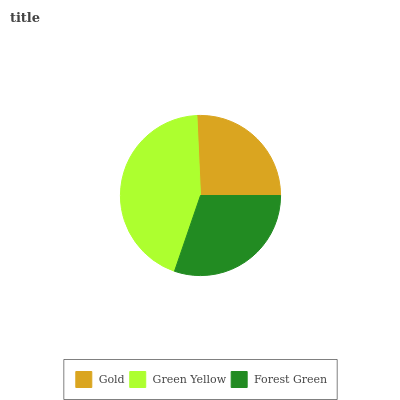Is Gold the minimum?
Answer yes or no. Yes. Is Green Yellow the maximum?
Answer yes or no. Yes. Is Forest Green the minimum?
Answer yes or no. No. Is Forest Green the maximum?
Answer yes or no. No. Is Green Yellow greater than Forest Green?
Answer yes or no. Yes. Is Forest Green less than Green Yellow?
Answer yes or no. Yes. Is Forest Green greater than Green Yellow?
Answer yes or no. No. Is Green Yellow less than Forest Green?
Answer yes or no. No. Is Forest Green the high median?
Answer yes or no. Yes. Is Forest Green the low median?
Answer yes or no. Yes. Is Green Yellow the high median?
Answer yes or no. No. Is Gold the low median?
Answer yes or no. No. 